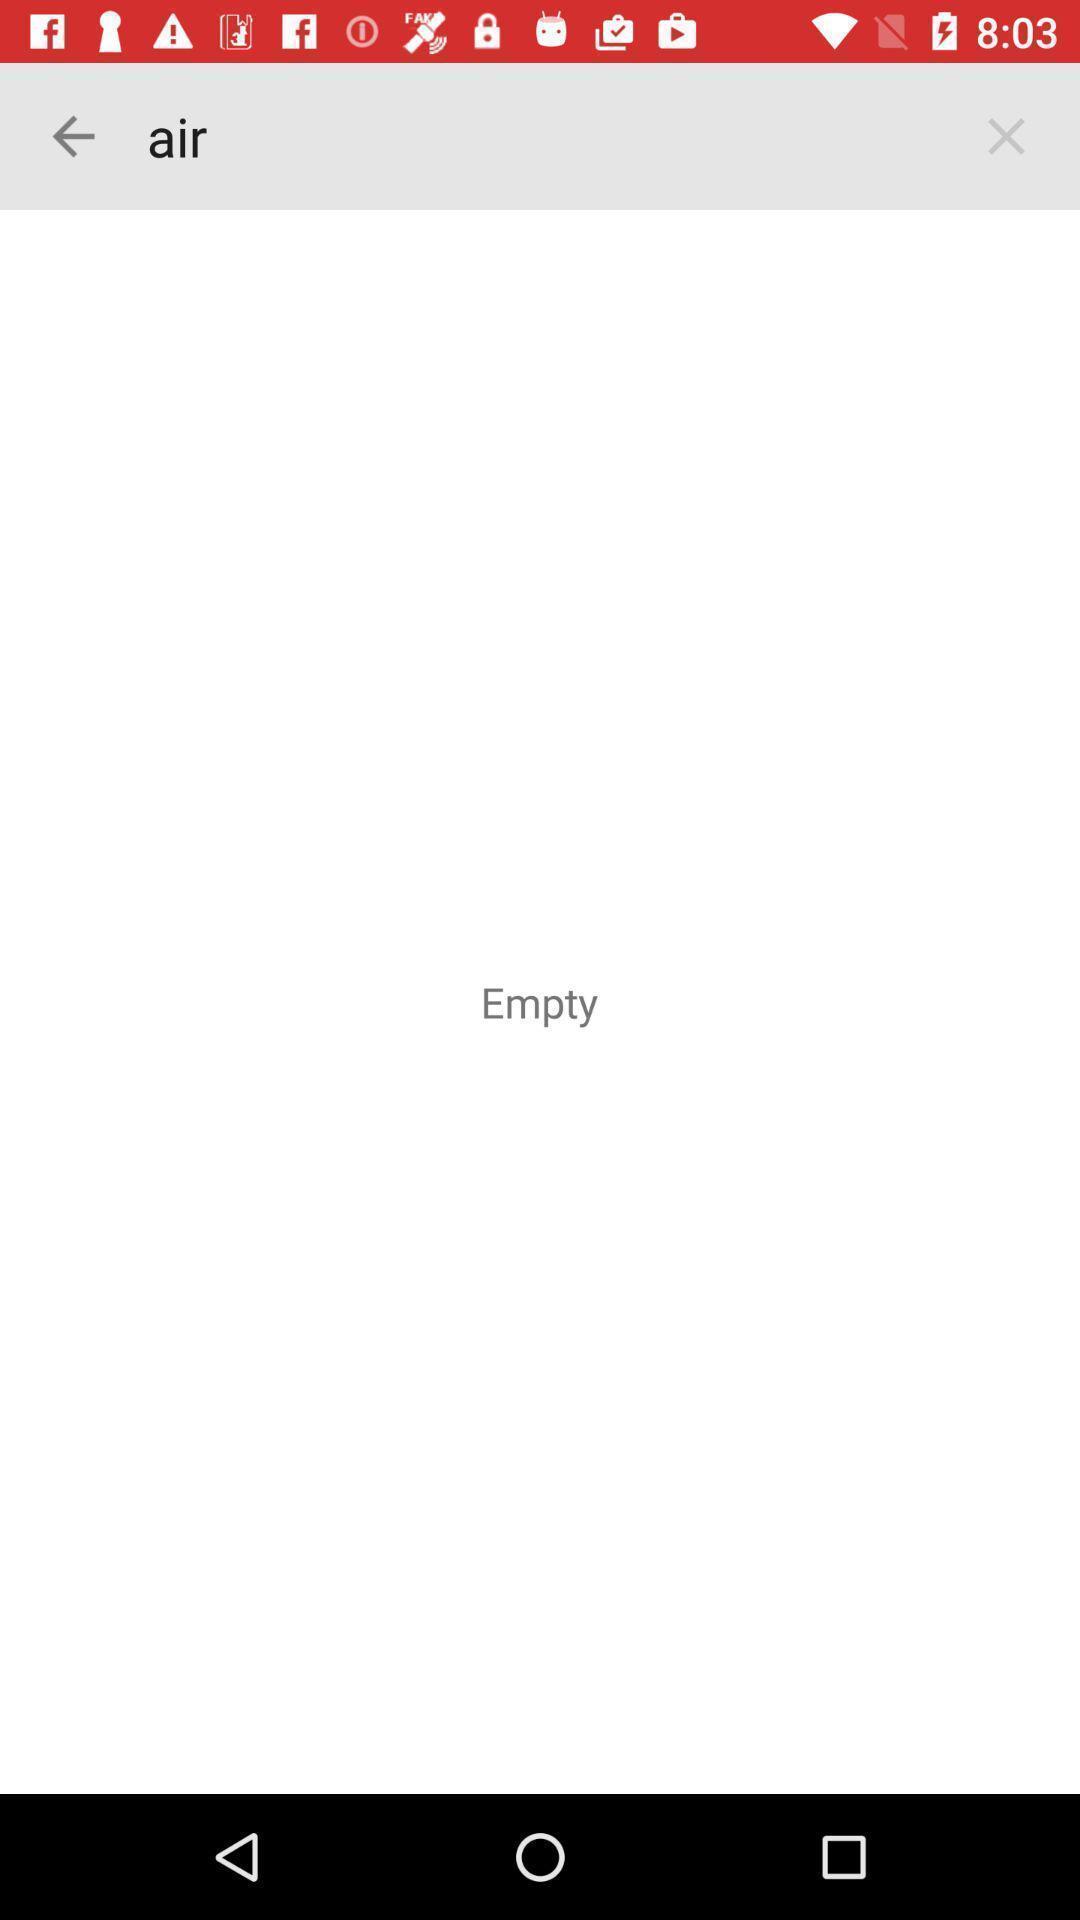Describe the content in this image. Page shows the empty air option. 